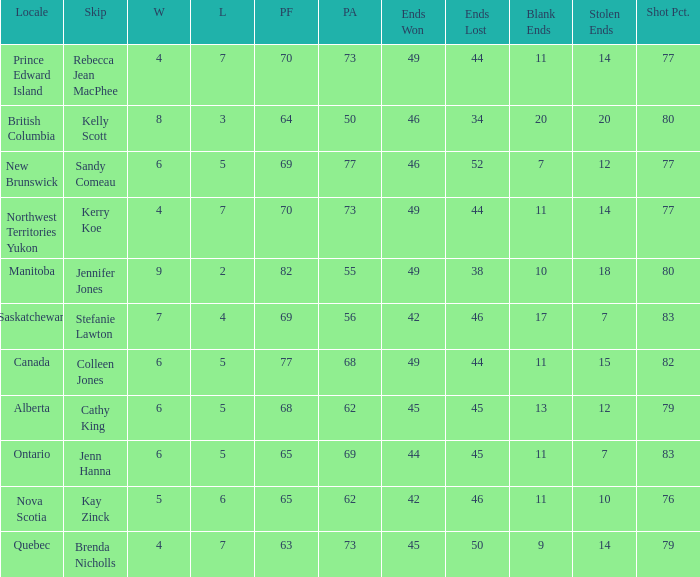What is the PA when the PF is 77? 68.0. 